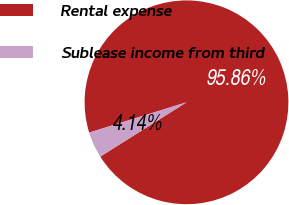Convert chart to OTSL. <chart><loc_0><loc_0><loc_500><loc_500><pie_chart><fcel>Rental expense<fcel>Sublease income from third<nl><fcel>95.86%<fcel>4.14%<nl></chart> 